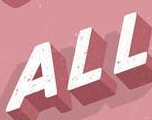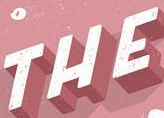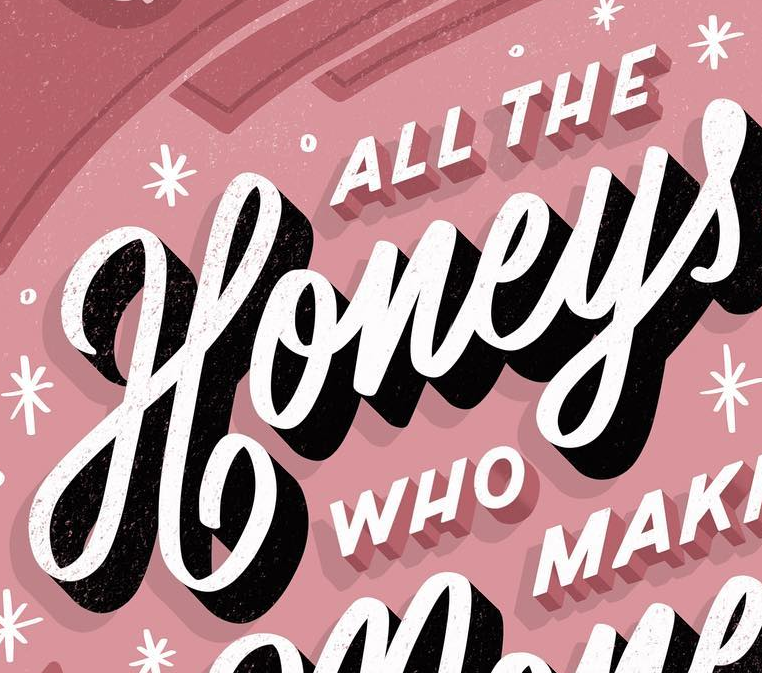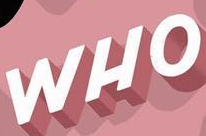What words are shown in these images in order, separated by a semicolon? ALL; THE; Honeys; WHO 